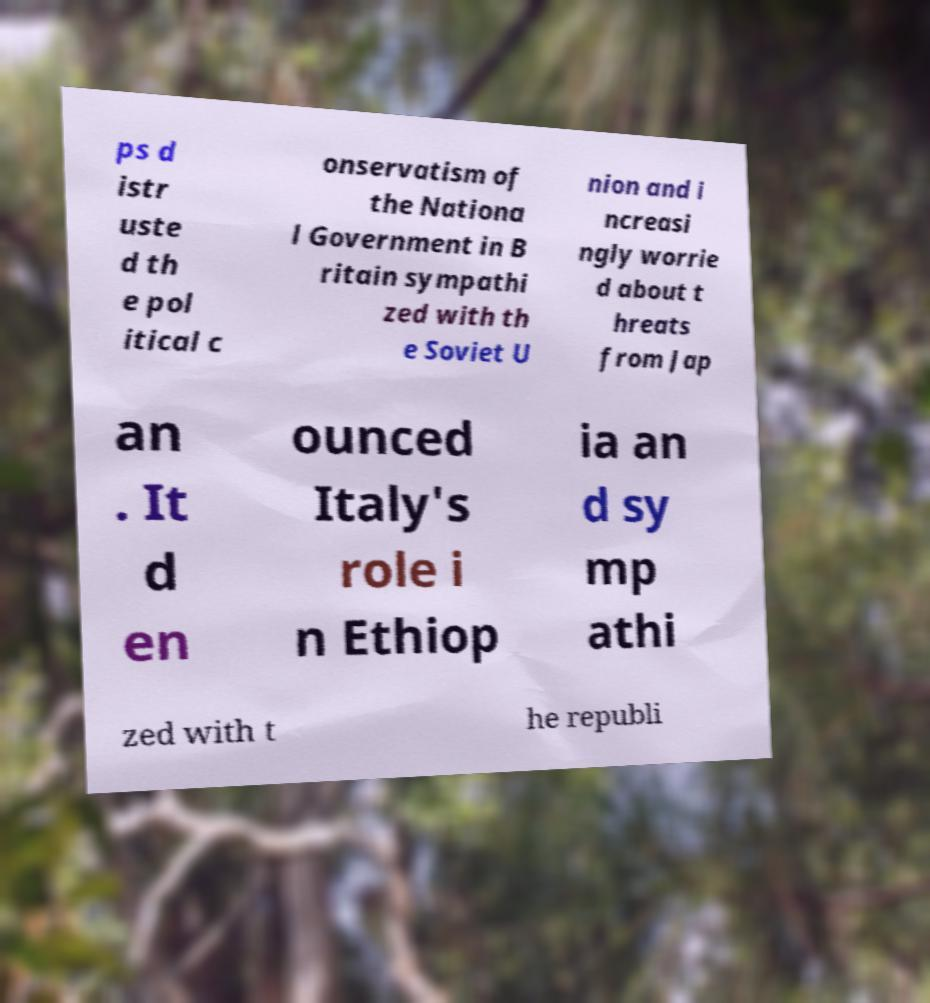What messages or text are displayed in this image? I need them in a readable, typed format. ps d istr uste d th e pol itical c onservatism of the Nationa l Government in B ritain sympathi zed with th e Soviet U nion and i ncreasi ngly worrie d about t hreats from Jap an . It d en ounced Italy's role i n Ethiop ia an d sy mp athi zed with t he republi 